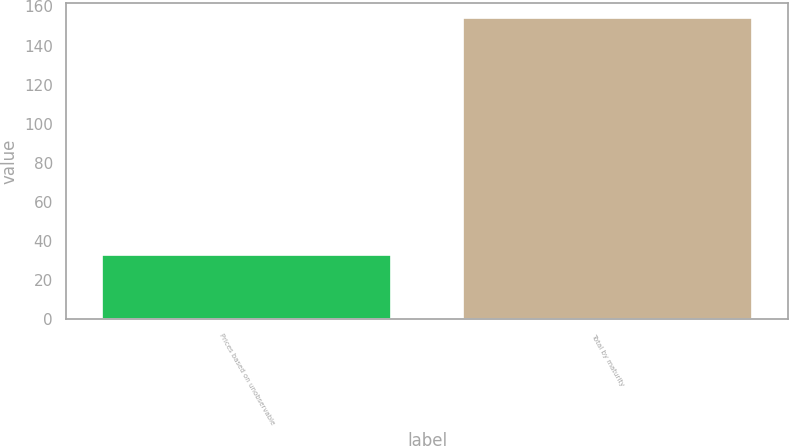Convert chart. <chart><loc_0><loc_0><loc_500><loc_500><bar_chart><fcel>Prices based on unobservable<fcel>Total by maturity<nl><fcel>33<fcel>154<nl></chart> 